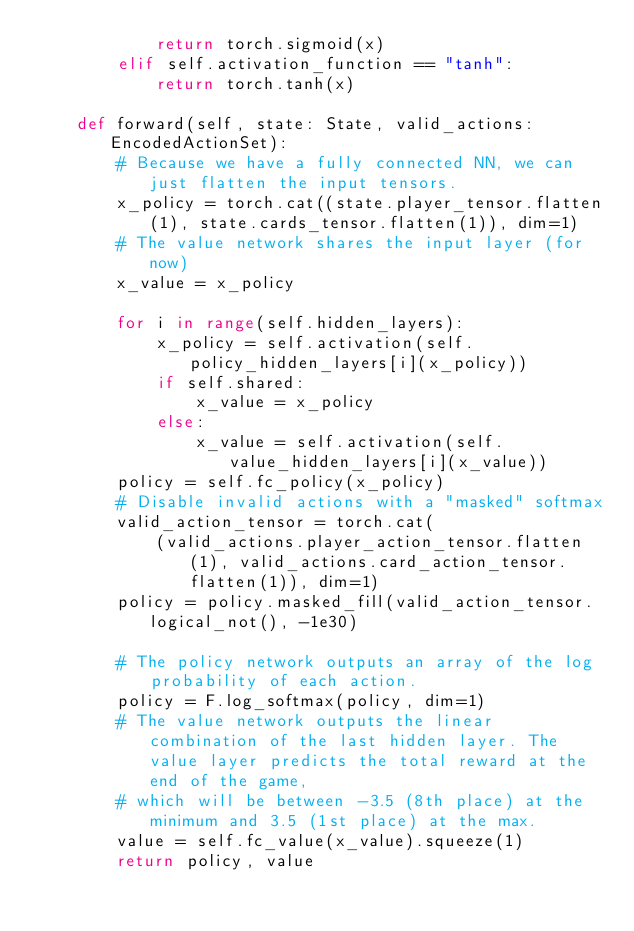Convert code to text. <code><loc_0><loc_0><loc_500><loc_500><_Python_>            return torch.sigmoid(x)
        elif self.activation_function == "tanh":
            return torch.tanh(x)

    def forward(self, state: State, valid_actions: EncodedActionSet):
        # Because we have a fully connected NN, we can just flatten the input tensors.
        x_policy = torch.cat((state.player_tensor.flatten(1), state.cards_tensor.flatten(1)), dim=1)
        # The value network shares the input layer (for now)
        x_value = x_policy

        for i in range(self.hidden_layers):
            x_policy = self.activation(self.policy_hidden_layers[i](x_policy))
            if self.shared:
                x_value = x_policy
            else:
                x_value = self.activation(self.value_hidden_layers[i](x_value))
        policy = self.fc_policy(x_policy)
        # Disable invalid actions with a "masked" softmax
        valid_action_tensor = torch.cat(
            (valid_actions.player_action_tensor.flatten(1), valid_actions.card_action_tensor.flatten(1)), dim=1)
        policy = policy.masked_fill(valid_action_tensor.logical_not(), -1e30)

        # The policy network outputs an array of the log probability of each action.
        policy = F.log_softmax(policy, dim=1)
        # The value network outputs the linear combination of the last hidden layer. The value layer predicts the total reward at the end of the game,
        # which will be between -3.5 (8th place) at the minimum and 3.5 (1st place) at the max. 
        value = self.fc_value(x_value).squeeze(1)
        return policy, value
</code> 